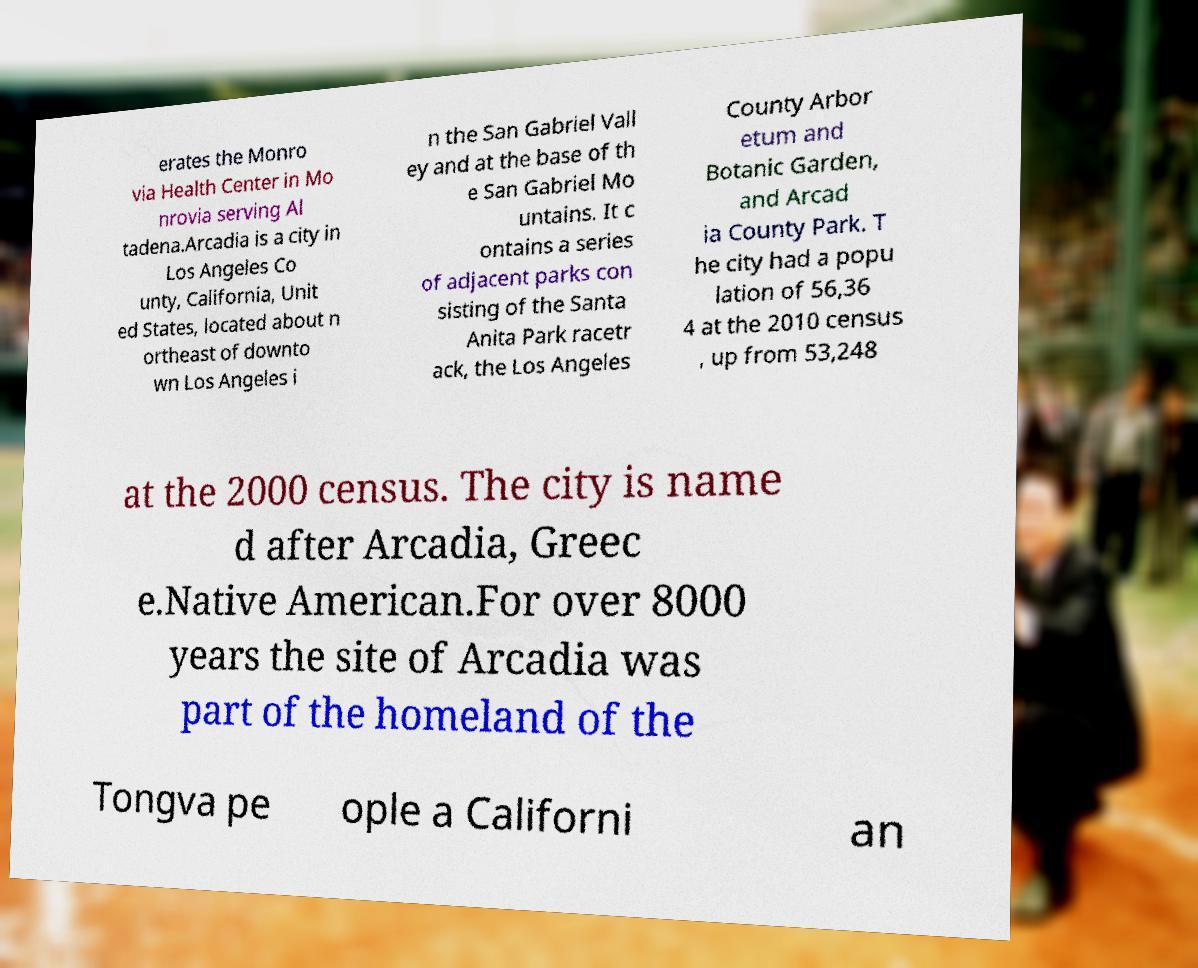Could you extract and type out the text from this image? erates the Monro via Health Center in Mo nrovia serving Al tadena.Arcadia is a city in Los Angeles Co unty, California, Unit ed States, located about n ortheast of downto wn Los Angeles i n the San Gabriel Vall ey and at the base of th e San Gabriel Mo untains. It c ontains a series of adjacent parks con sisting of the Santa Anita Park racetr ack, the Los Angeles County Arbor etum and Botanic Garden, and Arcad ia County Park. T he city had a popu lation of 56,36 4 at the 2010 census , up from 53,248 at the 2000 census. The city is name d after Arcadia, Greec e.Native American.For over 8000 years the site of Arcadia was part of the homeland of the Tongva pe ople a Californi an 